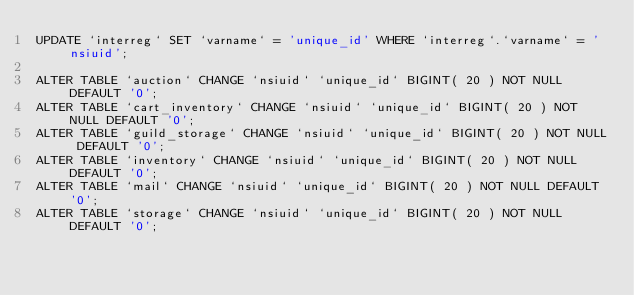<code> <loc_0><loc_0><loc_500><loc_500><_SQL_>UPDATE `interreg` SET `varname` = 'unique_id' WHERE `interreg`.`varname` = 'nsiuid';

ALTER TABLE `auction` CHANGE `nsiuid` `unique_id` BIGINT( 20 ) NOT NULL DEFAULT '0';
ALTER TABLE `cart_inventory` CHANGE `nsiuid` `unique_id` BIGINT( 20 ) NOT NULL DEFAULT '0';
ALTER TABLE `guild_storage` CHANGE `nsiuid` `unique_id` BIGINT( 20 ) NOT NULL DEFAULT '0';
ALTER TABLE `inventory` CHANGE `nsiuid` `unique_id` BIGINT( 20 ) NOT NULL DEFAULT '0';
ALTER TABLE `mail` CHANGE `nsiuid` `unique_id` BIGINT( 20 ) NOT NULL DEFAULT '0';
ALTER TABLE `storage` CHANGE `nsiuid` `unique_id` BIGINT( 20 ) NOT NULL DEFAULT '0';
</code> 